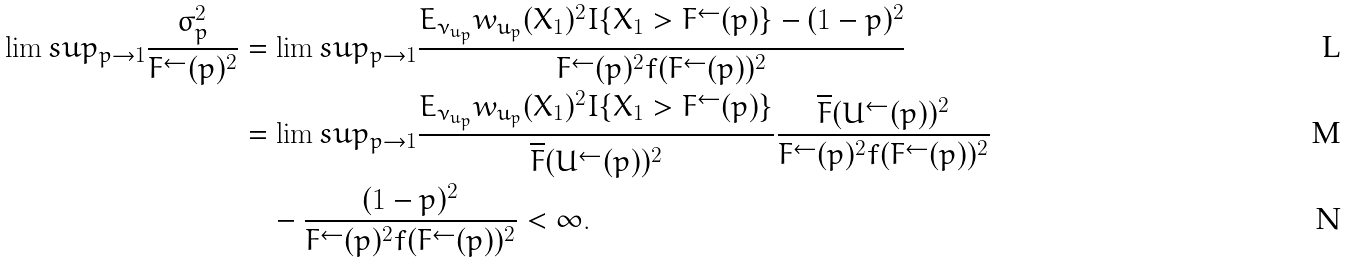Convert formula to latex. <formula><loc_0><loc_0><loc_500><loc_500>\lim s u p _ { p \to 1 } \frac { \sigma ^ { 2 } _ { p } } { F ^ { \leftarrow } ( p ) ^ { 2 } } & = \lim s u p _ { p \to 1 } \frac { E _ { \nu _ { u _ { p } } } w _ { u _ { p } } ( X _ { 1 } ) ^ { 2 } I \{ X _ { 1 } > F ^ { \leftarrow } ( p ) \} - ( 1 - p ) ^ { 2 } } { F ^ { \leftarrow } ( p ) ^ { 2 } f ( F ^ { \leftarrow } ( p ) ) ^ { 2 } } \\ & = \lim s u p _ { p \to 1 } \frac { E _ { \nu _ { u _ { p } } } w _ { u _ { p } } ( X _ { 1 } ) ^ { 2 } I \{ X _ { 1 } > F ^ { \leftarrow } ( p ) \} } { \overline { F } ( U ^ { \leftarrow } ( p ) ) ^ { 2 } } \frac { \overline { F } ( U ^ { \leftarrow } ( p ) ) ^ { 2 } } { F ^ { \leftarrow } ( p ) ^ { 2 } f ( F ^ { \leftarrow } ( p ) ) ^ { 2 } } \\ & \quad - \frac { ( 1 - p ) ^ { 2 } } { F ^ { \leftarrow } ( p ) ^ { 2 } f ( F ^ { \leftarrow } ( p ) ) ^ { 2 } } < \infty .</formula> 